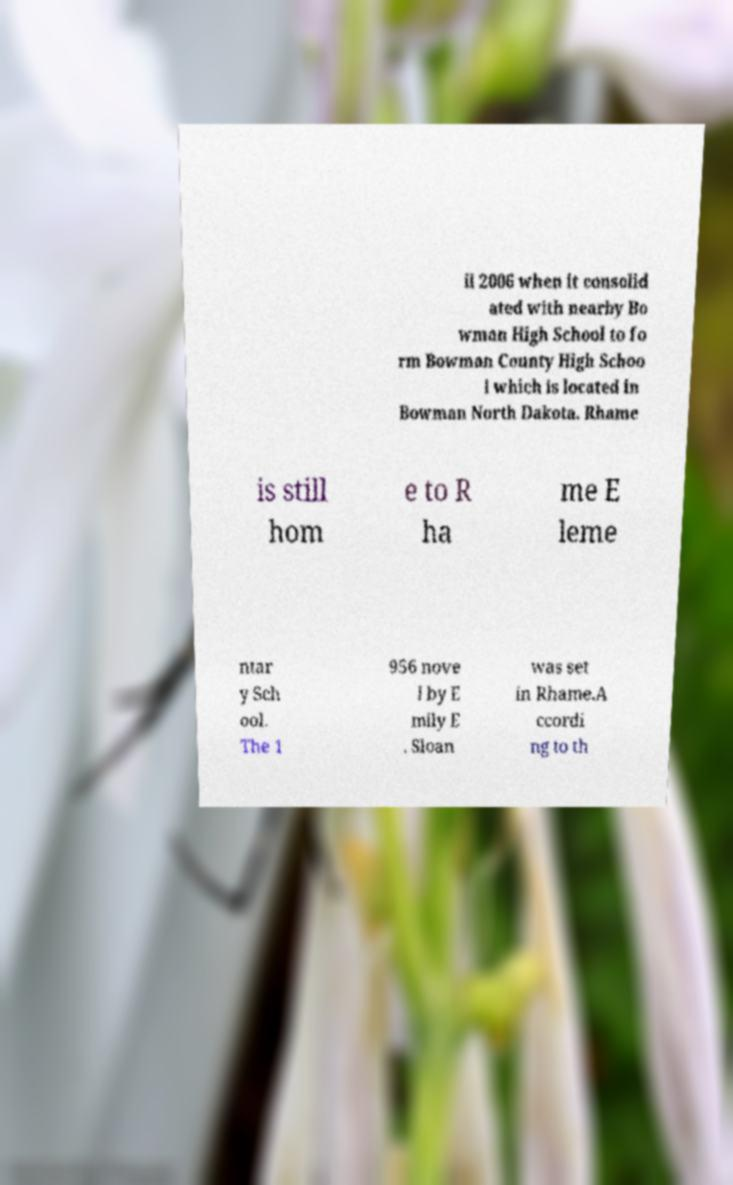Can you accurately transcribe the text from the provided image for me? il 2006 when it consolid ated with nearby Bo wman High School to fo rm Bowman County High Schoo l which is located in Bowman North Dakota. Rhame is still hom e to R ha me E leme ntar y Sch ool. The 1 956 nove l by E mily E . Sloan was set in Rhame.A ccordi ng to th 